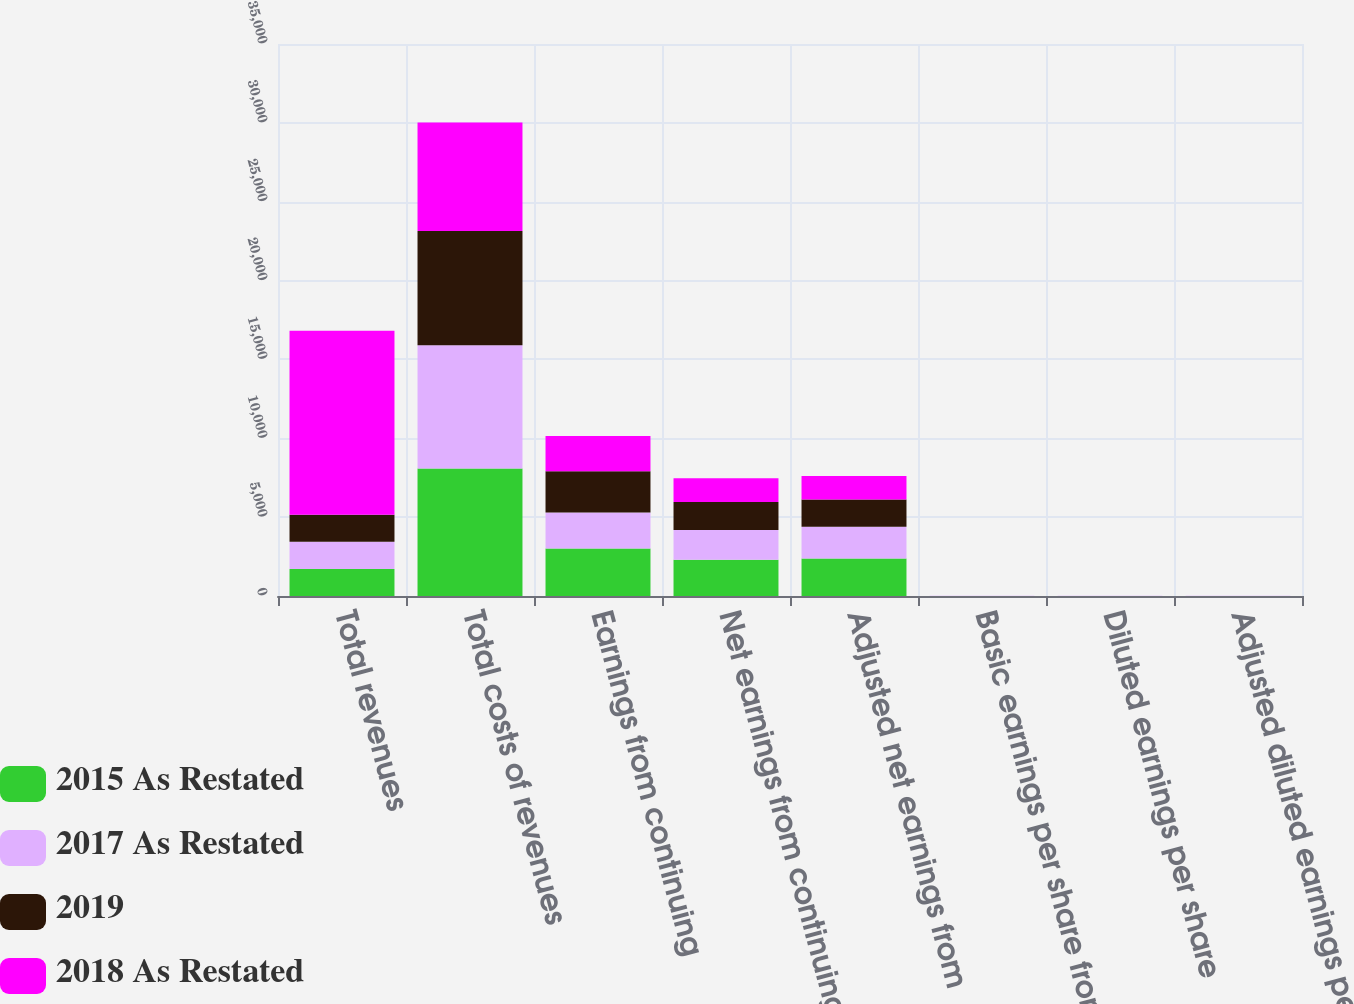Convert chart. <chart><loc_0><loc_0><loc_500><loc_500><stacked_bar_chart><ecel><fcel>Total revenues<fcel>Total costs of revenues<fcel>Earnings from continuing<fcel>Net earnings from continuing<fcel>Adjusted net earnings from<fcel>Basic earnings per share from<fcel>Diluted earnings per share<fcel>Adjusted diluted earnings per<nl><fcel>2015 As Restated<fcel>1719.4<fcel>8086.6<fcel>3005.6<fcel>2292.8<fcel>2384.3<fcel>5.27<fcel>5.24<fcel>5.45<nl><fcel>2017 As Restated<fcel>1719.4<fcel>7810.9<fcel>2282.6<fcel>1884.9<fcel>2007.3<fcel>4.28<fcel>4.25<fcel>4.53<nl><fcel>2019<fcel>1719.4<fcel>7244.5<fcel>2616.9<fcel>1787.8<fcel>1719.4<fcel>3.99<fcel>3.97<fcel>3.82<nl><fcel>2018 As Restated<fcel>11667.8<fcel>6876.1<fcel>2234.7<fcel>1493.4<fcel>1494.8<fcel>3.27<fcel>3.25<fcel>3.26<nl></chart> 